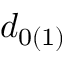<formula> <loc_0><loc_0><loc_500><loc_500>d _ { 0 ( 1 ) }</formula> 